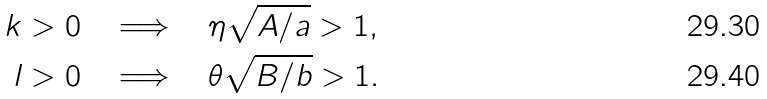Convert formula to latex. <formula><loc_0><loc_0><loc_500><loc_500>k > 0 \quad & \Longrightarrow \quad \eta \sqrt { A / a } > 1 , \\ l > 0 \quad & \Longrightarrow \quad \theta \sqrt { B / b } > 1 .</formula> 